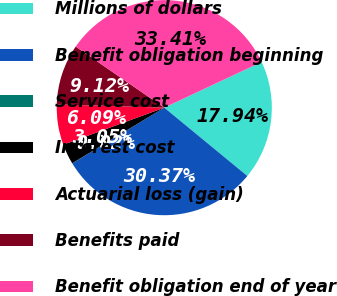<chart> <loc_0><loc_0><loc_500><loc_500><pie_chart><fcel>Millions of dollars<fcel>Benefit obligation beginning<fcel>Service cost<fcel>Interest cost<fcel>Actuarial loss (gain)<fcel>Benefits paid<fcel>Benefit obligation end of year<nl><fcel>17.94%<fcel>30.37%<fcel>0.02%<fcel>3.05%<fcel>6.09%<fcel>9.12%<fcel>33.41%<nl></chart> 